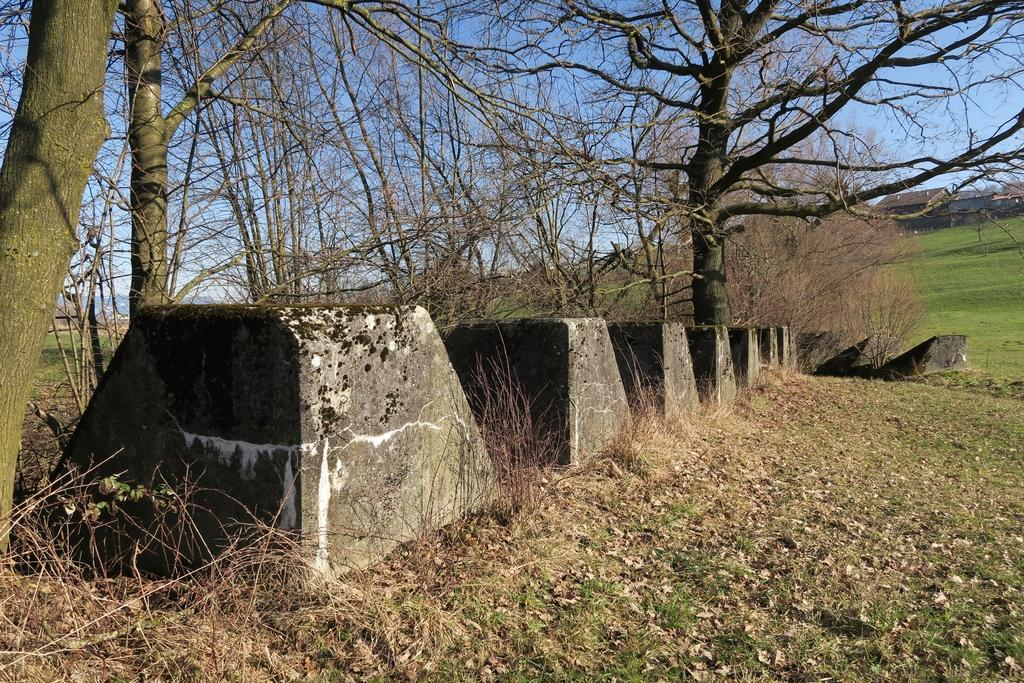What type of vegetation is present in the image? There are trees in the image. What is the ground covered with in the image? There is dried grass in the image. What other natural elements can be seen in the image? There appear to be rocks in the image. Can you describe any man-made structures in the background of the image? There may be a house in the background of the image, but this is less certain due to the ambiguity in the transcript. What type of muscle can be seen flexing in the image? There is no muscle present in the image; it features natural elements such as trees, dried grass, and rocks. 